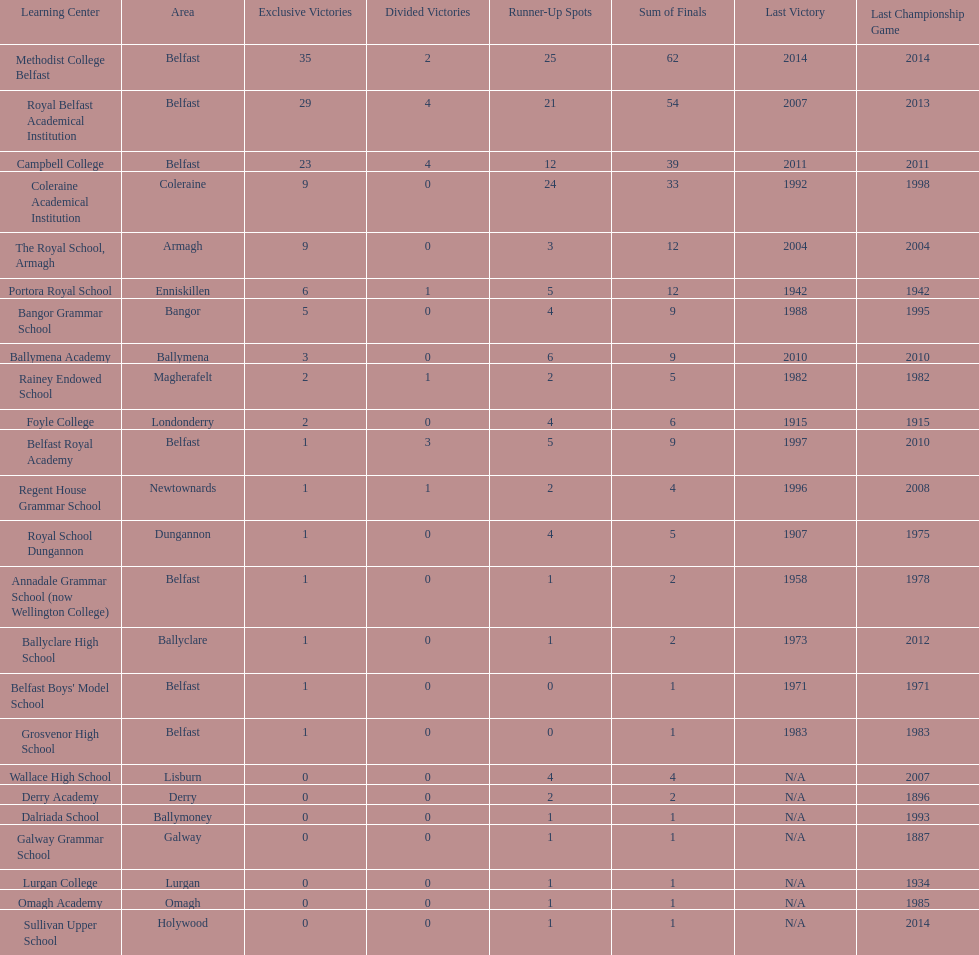Which school has the same number of outright titles as the coleraine academical institution? The Royal School, Armagh. 